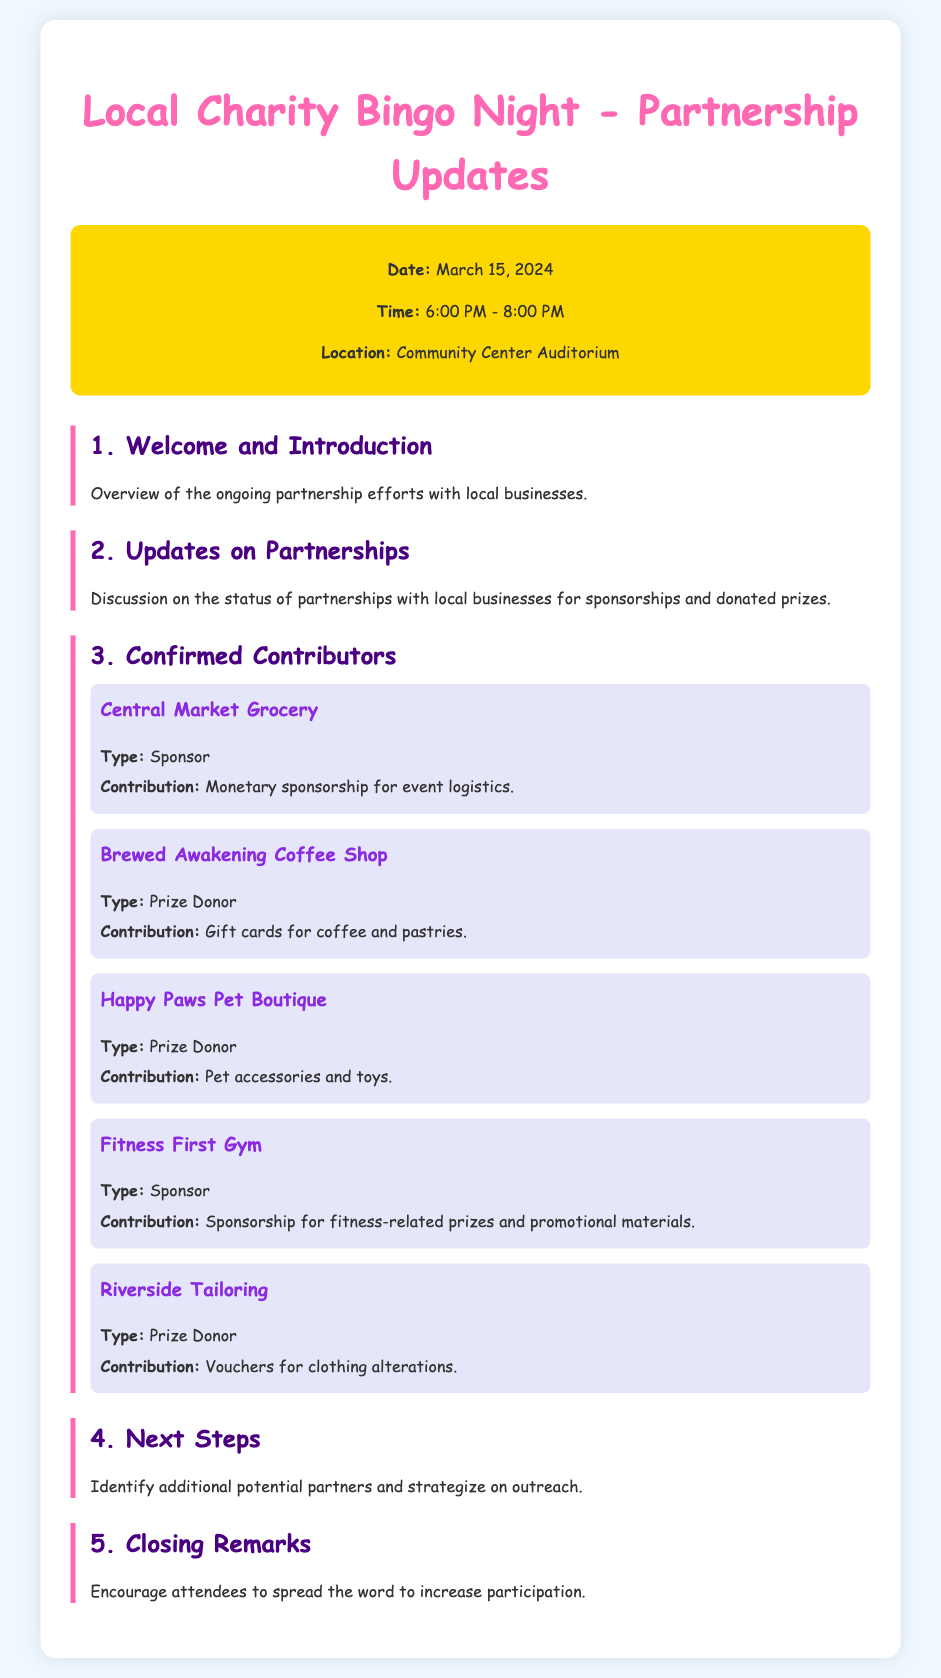What is the date of the event? The date of the event is specified in the event details section of the document.
Answer: March 15, 2024 What time does the event start? The time is included in the event details section, indicating the start time.
Answer: 6:00 PM Which business is a sponsor? The contributor section lists businesses along with their type, indicating sponsorship.
Answer: Central Market Grocery What contribution did Brewed Awakening Coffee Shop provide? The contribution details are provided for each confirmed contributor, specifying what they donated.
Answer: Gift cards for coffee and pastries How many confirmed contributors are listed? The contributors are explicitly listed, allowing us to count them.
Answer: 5 What is the focus of the next steps in the agenda? The next steps section outlines key tasks emerging from the discussion about partnerships.
Answer: Identify additional potential partners What color is used for the document's main title? The document specifies the color in the styling section for the title.
Answer: Pink What type of document is this? The document's title informs us of its purpose related to community activities.
Answer: Agenda 